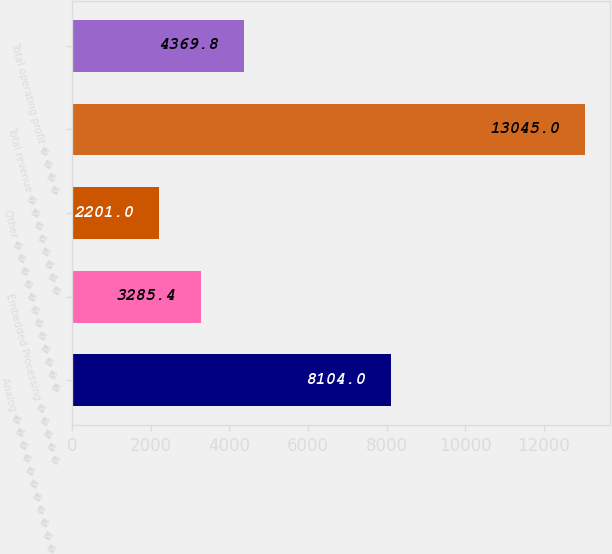<chart> <loc_0><loc_0><loc_500><loc_500><bar_chart><fcel>Analog � � � � � � � � � � � �<fcel>Embedded Processing � � � � �<fcel>Other � � � � � � � � � � � �<fcel>Total revenue � � � � � � � �<fcel>Total operating profit � � � �<nl><fcel>8104<fcel>3285.4<fcel>2201<fcel>13045<fcel>4369.8<nl></chart> 